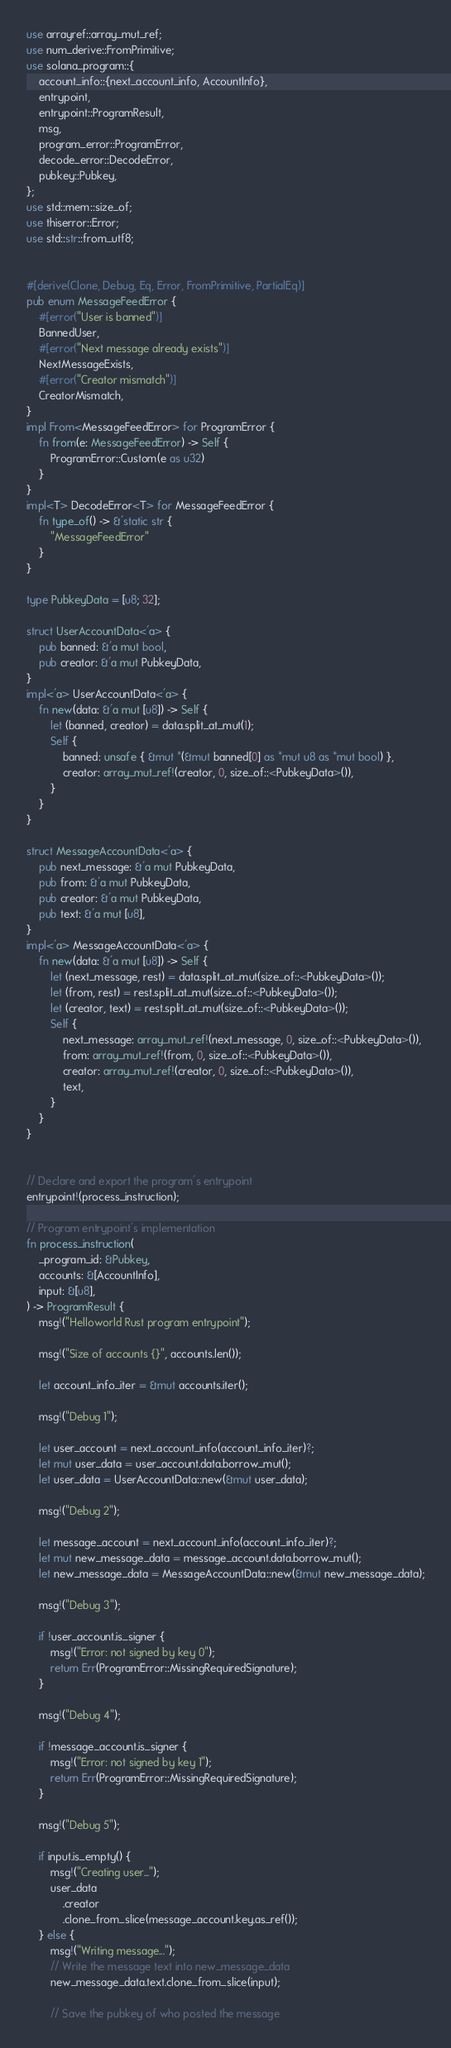Convert code to text. <code><loc_0><loc_0><loc_500><loc_500><_Rust_>use arrayref::array_mut_ref;
use num_derive::FromPrimitive;
use solana_program::{
    account_info::{next_account_info, AccountInfo},
    entrypoint,
    entrypoint::ProgramResult,
    msg,
    program_error::ProgramError,
    decode_error::DecodeError,
    pubkey::Pubkey,
};
use std::mem::size_of;
use thiserror::Error;
use std::str::from_utf8;


#[derive(Clone, Debug, Eq, Error, FromPrimitive, PartialEq)]
pub enum MessageFeedError {
    #[error("User is banned")]
    BannedUser,
    #[error("Next message already exists")]
    NextMessageExists,
    #[error("Creator mismatch")]
    CreatorMismatch,
}
impl From<MessageFeedError> for ProgramError {
    fn from(e: MessageFeedError) -> Self {
        ProgramError::Custom(e as u32)
    }
}
impl<T> DecodeError<T> for MessageFeedError {
    fn type_of() -> &'static str {
        "MessageFeedError"
    }
}

type PubkeyData = [u8; 32];

struct UserAccountData<'a> {
    pub banned: &'a mut bool,
    pub creator: &'a mut PubkeyData,
}
impl<'a> UserAccountData<'a> {
    fn new(data: &'a mut [u8]) -> Self {
        let (banned, creator) = data.split_at_mut(1);
        Self {
            banned: unsafe { &mut *(&mut banned[0] as *mut u8 as *mut bool) },
            creator: array_mut_ref!(creator, 0, size_of::<PubkeyData>()),
        }
    }
}

struct MessageAccountData<'a> {
    pub next_message: &'a mut PubkeyData,
    pub from: &'a mut PubkeyData,
    pub creator: &'a mut PubkeyData,
    pub text: &'a mut [u8],
}
impl<'a> MessageAccountData<'a> {
    fn new(data: &'a mut [u8]) -> Self {
        let (next_message, rest) = data.split_at_mut(size_of::<PubkeyData>());
        let (from, rest) = rest.split_at_mut(size_of::<PubkeyData>());
        let (creator, text) = rest.split_at_mut(size_of::<PubkeyData>());
        Self {
            next_message: array_mut_ref!(next_message, 0, size_of::<PubkeyData>()),
            from: array_mut_ref!(from, 0, size_of::<PubkeyData>()),
            creator: array_mut_ref!(creator, 0, size_of::<PubkeyData>()),
            text,
        }
    }
}


// Declare and export the program's entrypoint
entrypoint!(process_instruction);

// Program entrypoint's implementation
fn process_instruction(
    _program_id: &Pubkey,
    accounts: &[AccountInfo],
    input: &[u8],
) -> ProgramResult {
    msg!("Helloworld Rust program entrypoint");

    msg!("Size of accounts {}", accounts.len());

    let account_info_iter = &mut accounts.iter();

    msg!("Debug 1");

    let user_account = next_account_info(account_info_iter)?;
    let mut user_data = user_account.data.borrow_mut();
    let user_data = UserAccountData::new(&mut user_data);
    
    msg!("Debug 2");

    let message_account = next_account_info(account_info_iter)?;
    let mut new_message_data = message_account.data.borrow_mut();
    let new_message_data = MessageAccountData::new(&mut new_message_data);

    msg!("Debug 3");

    if !user_account.is_signer {
        msg!("Error: not signed by key 0");
        return Err(ProgramError::MissingRequiredSignature);
    }

    msg!("Debug 4");

    if !message_account.is_signer {
        msg!("Error: not signed by key 1");
        return Err(ProgramError::MissingRequiredSignature);
    }

    msg!("Debug 5");

    if input.is_empty() {
        msg!("Creating user...");
        user_data
            .creator
            .clone_from_slice(message_account.key.as_ref());
    } else {
        msg!("Writing message...");
        // Write the message text into new_message_data
        new_message_data.text.clone_from_slice(input);

        // Save the pubkey of who posted the message</code> 